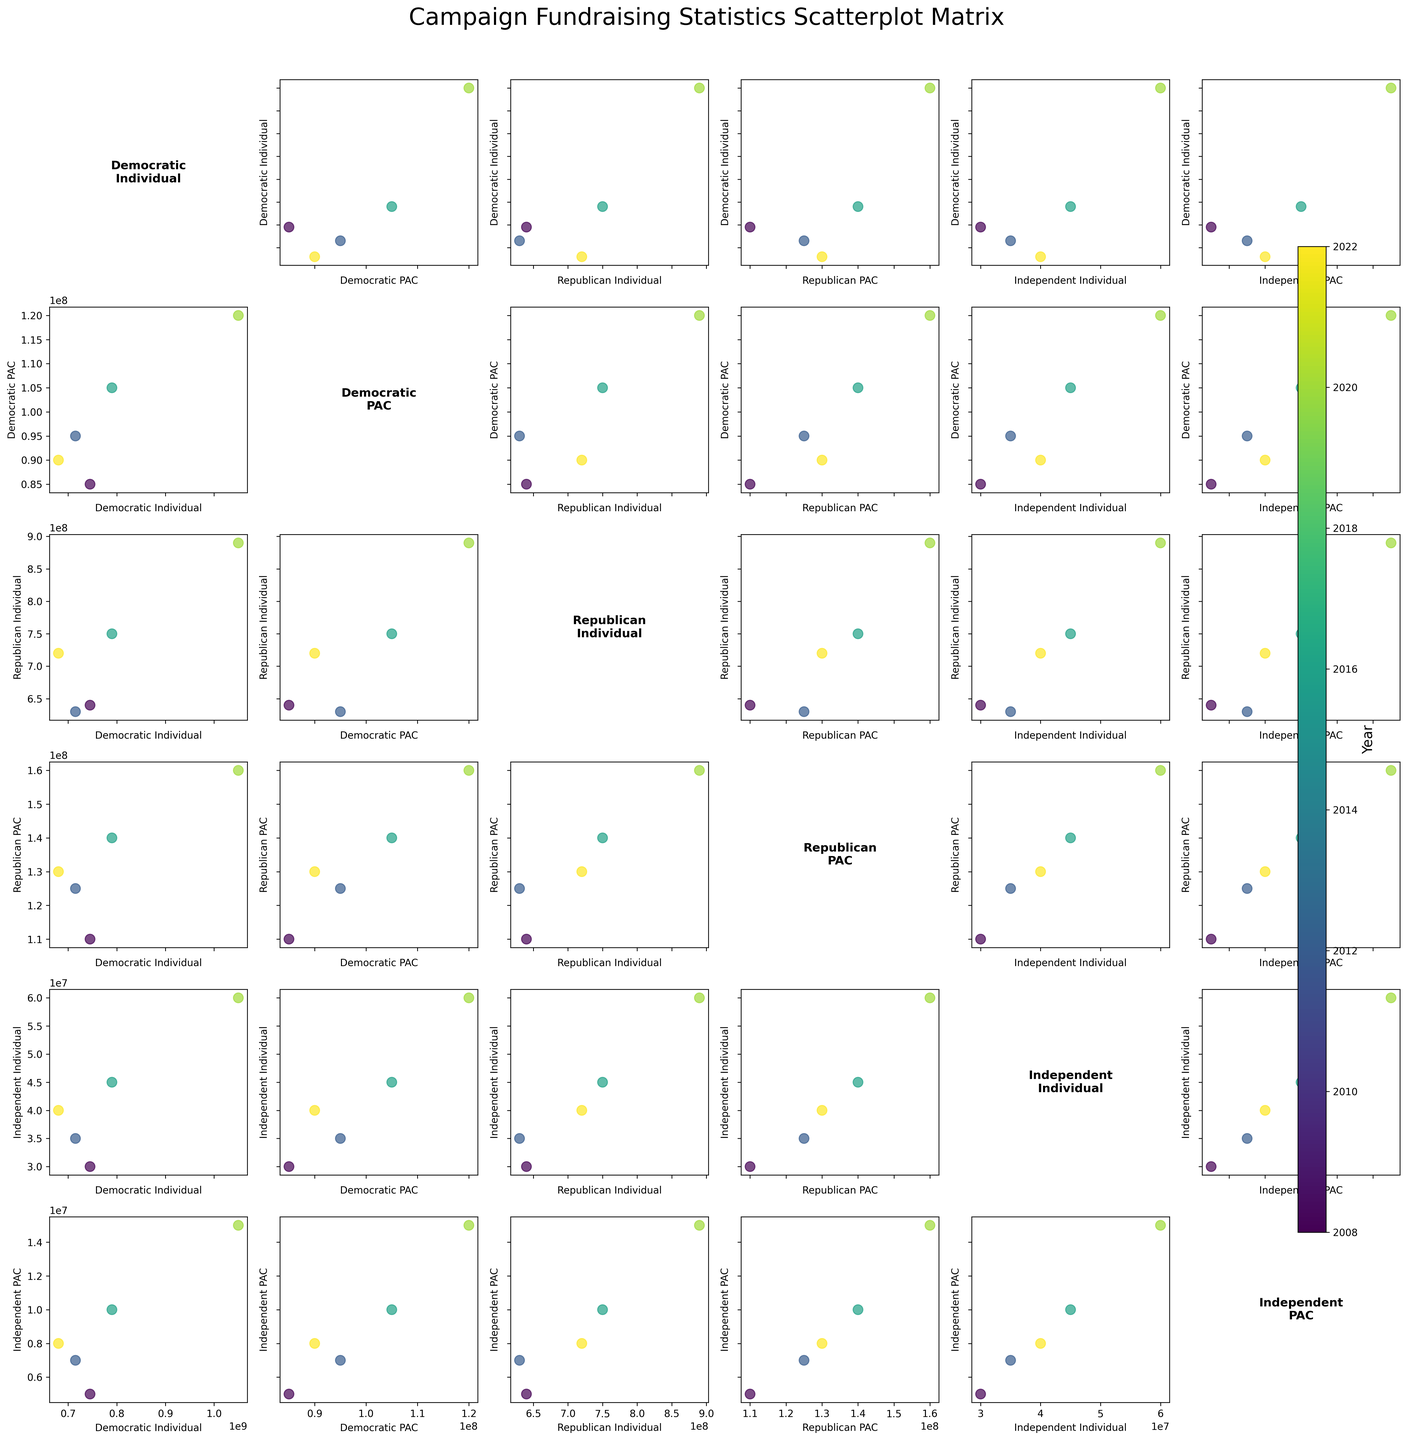What is the title of the figure? The title is at the top of the figure, directly above the scatterplot matrix.
Answer: Campaign Fundraising Statistics Scatterplot Matrix Which color represents the earliest year in the dataset? The color representing the earliest year in the dataset can be inferred from the colorbar on the right.
Answer: Dark color (often dark blue) Which variable shows the highest individual contributions for 2020? By examining the scatter plots for 2020 across variables indicating years, it's noticeable where the highest individual donations peak.
Answer: Democratic Individual Comparing Democratic PAC contributions to Independent PAC contributions in 2012, which is larger? Locate points for the year 2012 in both Democratic PAC and Independent PAC scatter plots. Compare values visually.
Answer: Democratic PAC Which year has the least variability (spread) in Democratic Individual contributions? By inspecting the scatter plots of Democratic Individual contributions for each year, look for the year with the smallest range in data points.
Answer: 2022 What was the difference between Democratic Individual contributions and Republican Individual contributions in 2016? Identify the Democratic and Republican Individual contributions for 2016 in the scatter plot and calculate the difference.
Answer: 40,000,000 (790,000,000 - 750,000,000) In which year do PAC contributions for Republicans exceed those for Democrats? Examine the scatter plots for Republican PAC versus Democratic PAC contributions across years, identifying any crossover points.
Answer: 2008 Is there any correlation noticeable between Independent Individual contributions and Democratic Individual contributions? Look at the scatter plot of Independent Individual versus Democratic Individual contributions to determine if a pattern or trend is visible.
Answer: Positive correlation Which variable tends to have higher contributions, Republican Individual or Democratic PAC? By comparing scatter plots between Republican Individual and Democratic PAC, visually assess which tends to have higher values across years.
Answer: Republican Individual Are independent contributions consistently the lowest across all years? Review scatter plots for all political party contributions across years to verify if independent contributions remain the lowest.
Answer: Yes 